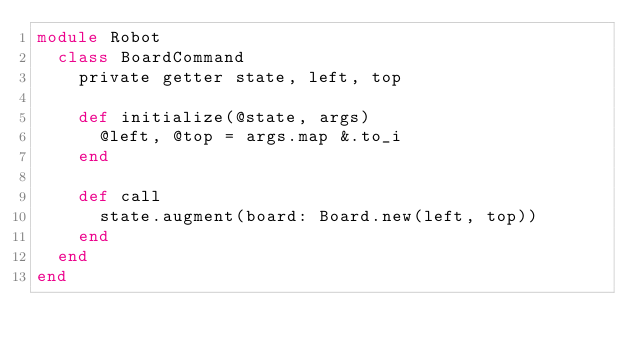Convert code to text. <code><loc_0><loc_0><loc_500><loc_500><_Crystal_>module Robot
  class BoardCommand
    private getter state, left, top

    def initialize(@state, args)
      @left, @top = args.map &.to_i
    end

    def call
      state.augment(board: Board.new(left, top))
    end
  end
end
</code> 